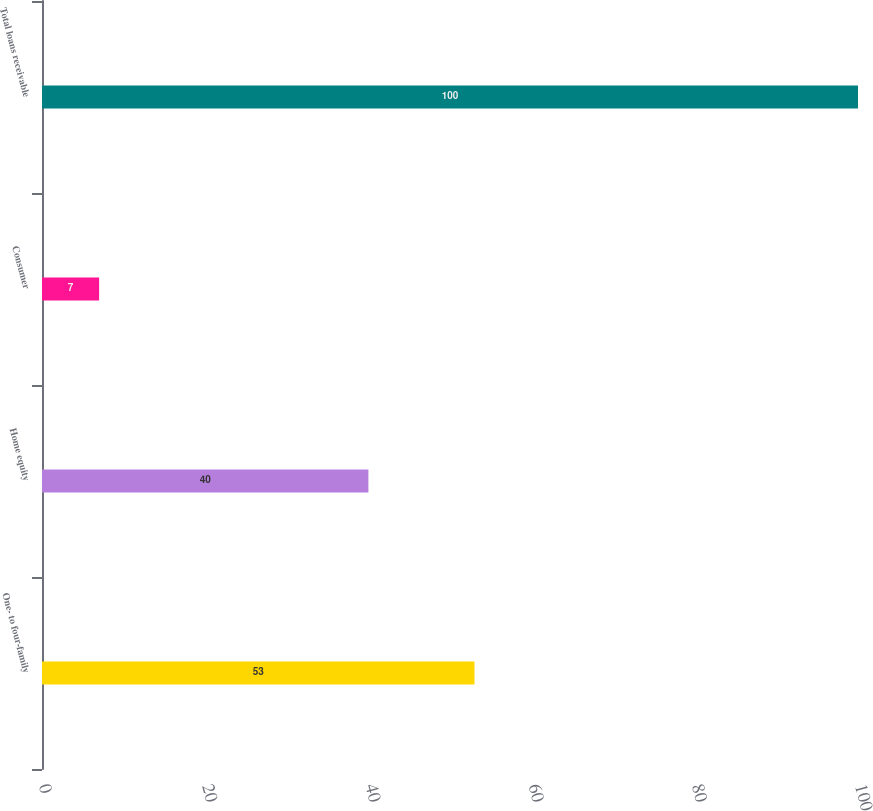<chart> <loc_0><loc_0><loc_500><loc_500><bar_chart><fcel>One- to four-family<fcel>Home equity<fcel>Consumer<fcel>Total loans receivable<nl><fcel>53<fcel>40<fcel>7<fcel>100<nl></chart> 